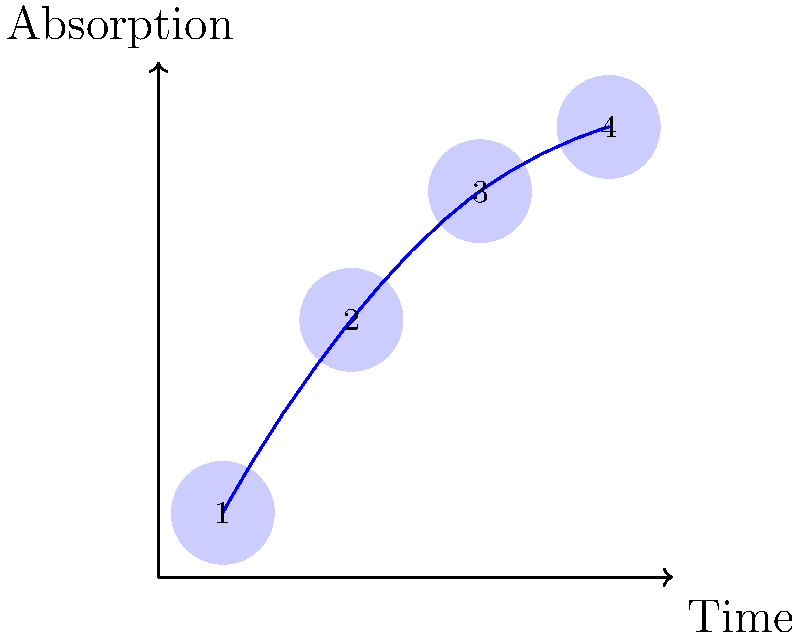In the drug absorption sequence shown, which stage represents the point of maximum absorption rate? To determine the stage of maximum absorption rate, we need to analyze the curve's steepness at each stage:

1. Stage 1 to 2: The curve shows a steep increase, indicating rapid absorption.
2. Stage 2 to 3: The curve continues to rise but with a slightly decreased slope, suggesting the absorption rate is still increasing but at a slower pace.
3. Stage 3 to 4: The curve begins to level off, indicating a decrease in absorption rate.

The maximum absorption rate occurs at the point where the curve has the steepest slope, which is between stages 1 and 2. This is where the change in absorption per unit time is greatest.

Stage 2 represents the end of this maximum rate period, just before the absorption rate begins to slow down.
Answer: Stage 2 